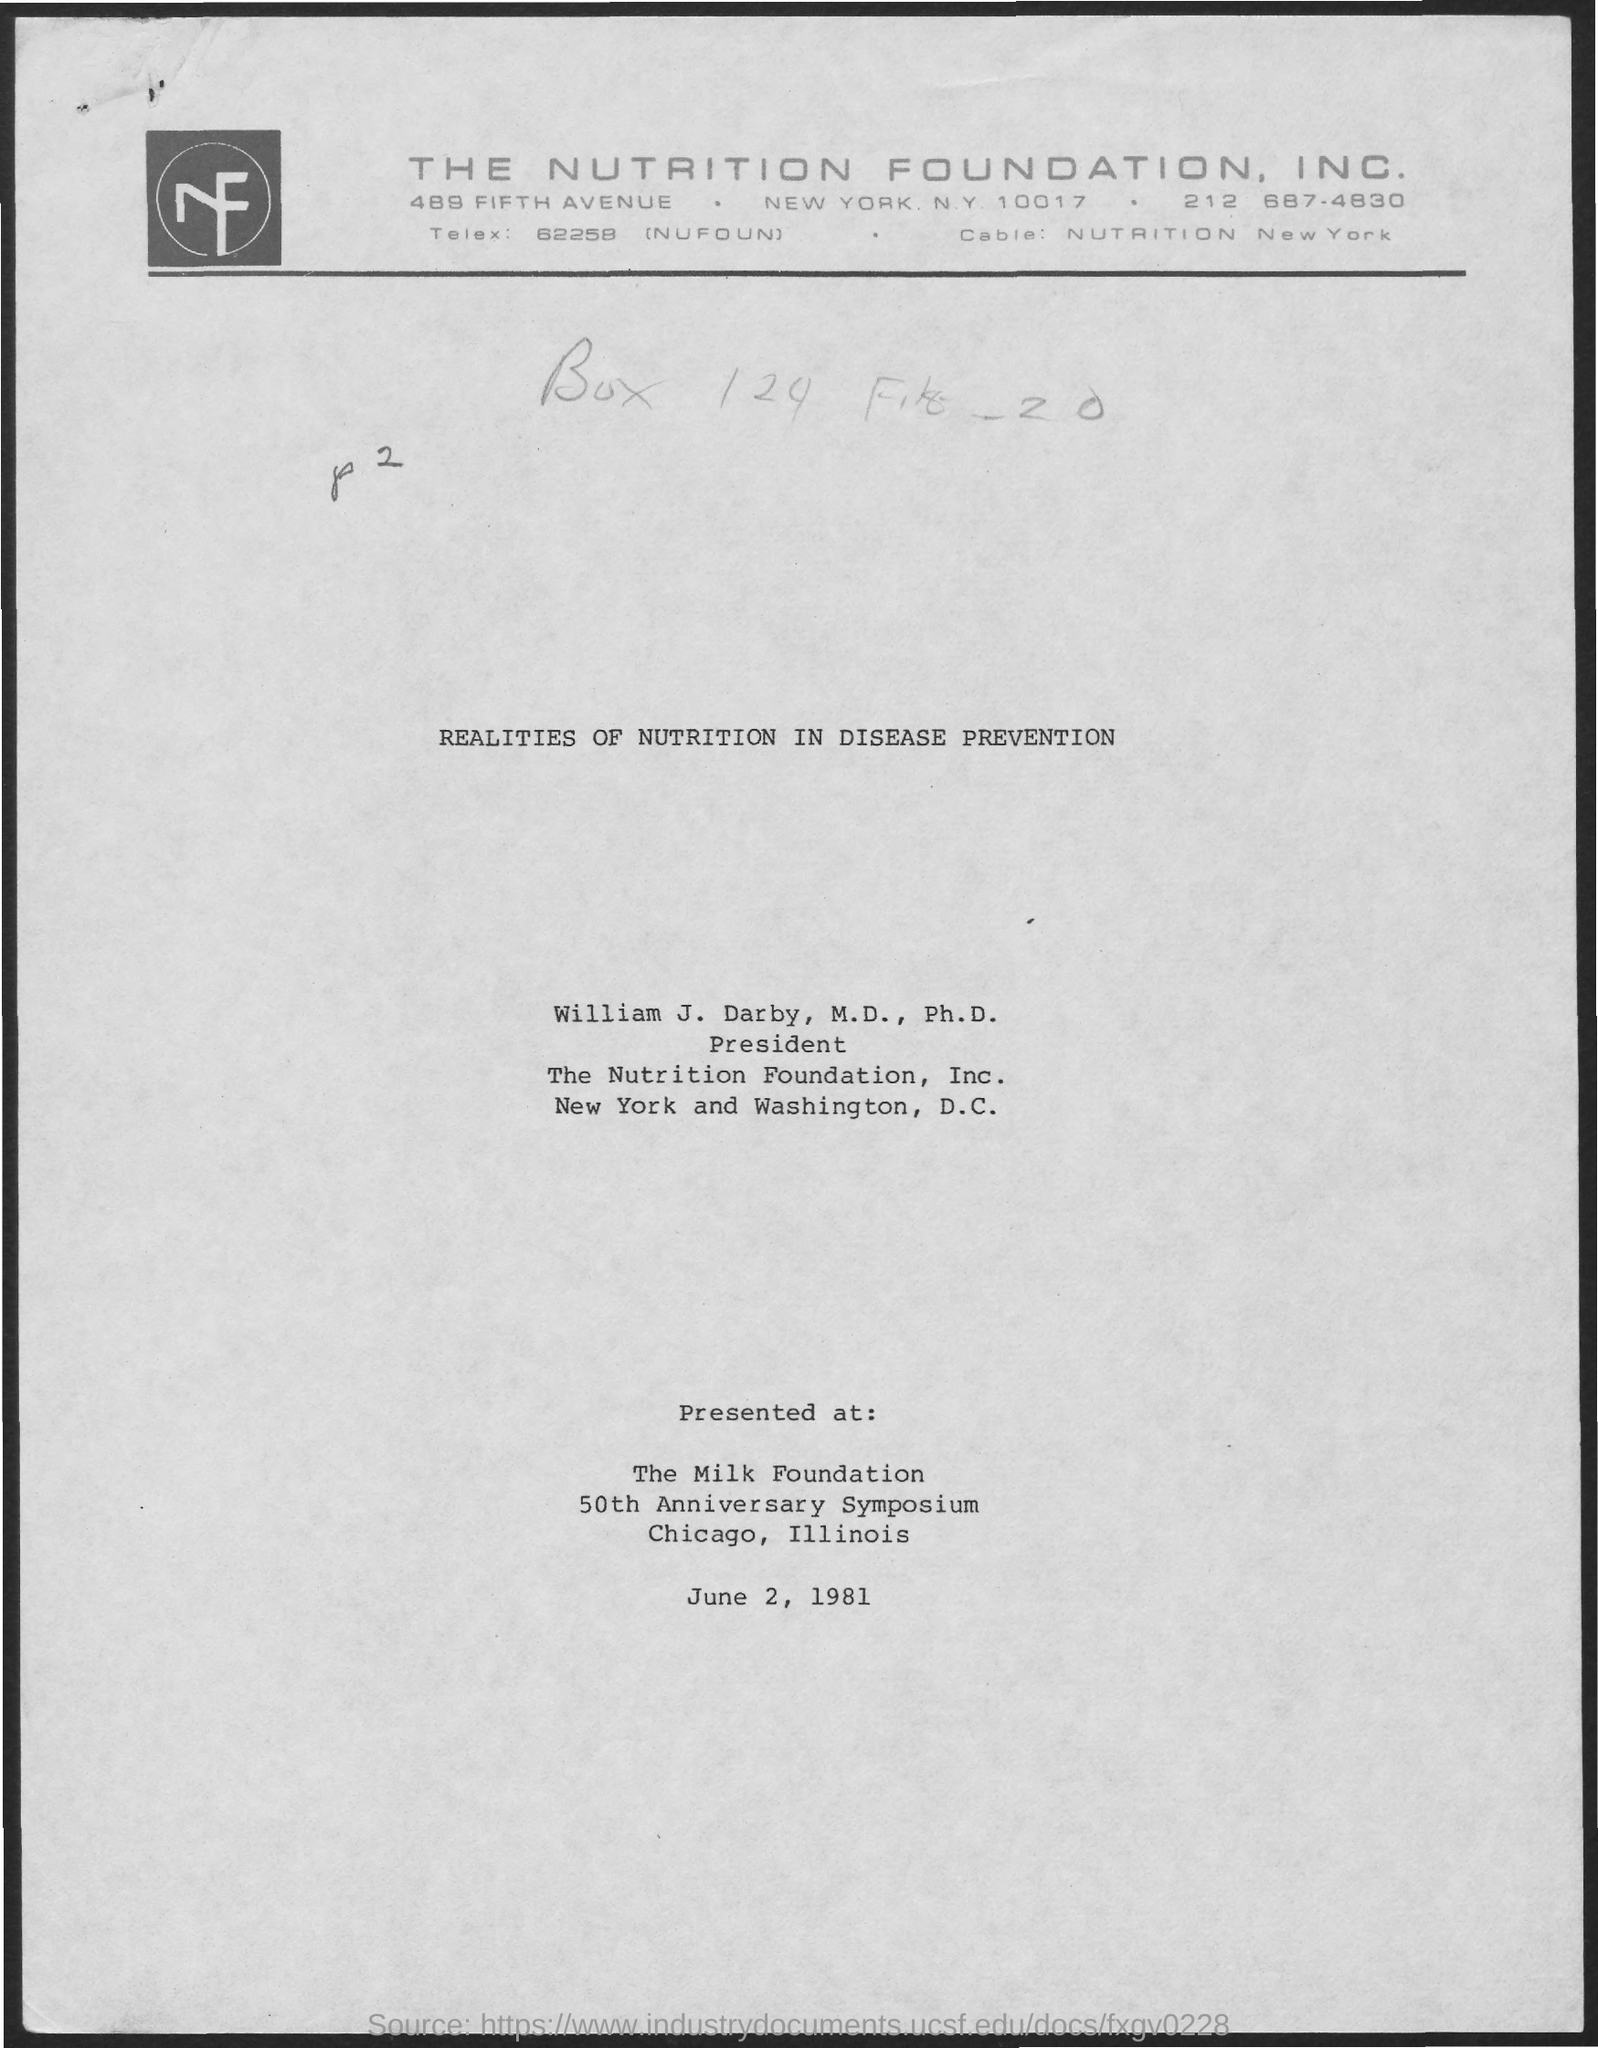What is the date mentioned in document?
Your response must be concise. June 2, 1981. 